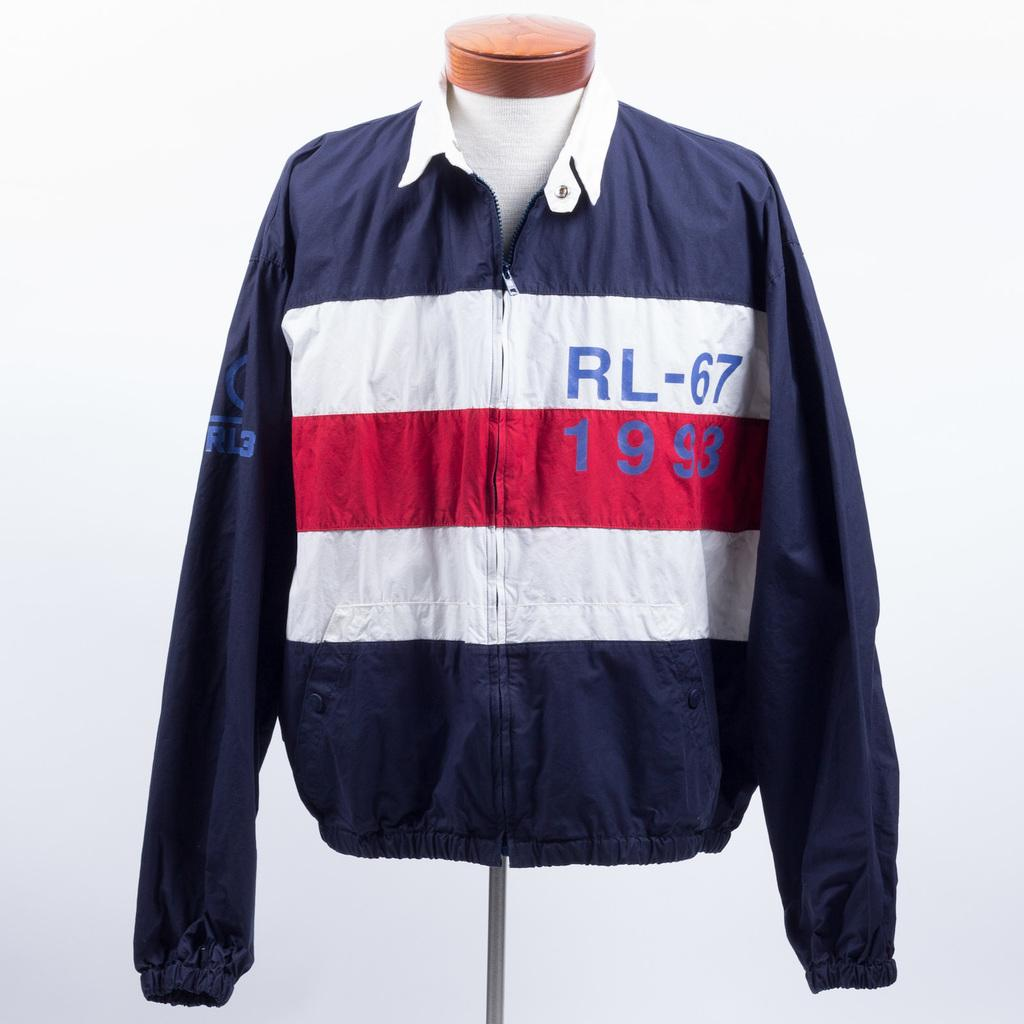<image>
Render a clear and concise summary of the photo. a jacket with the letters RL on it and the number 67 